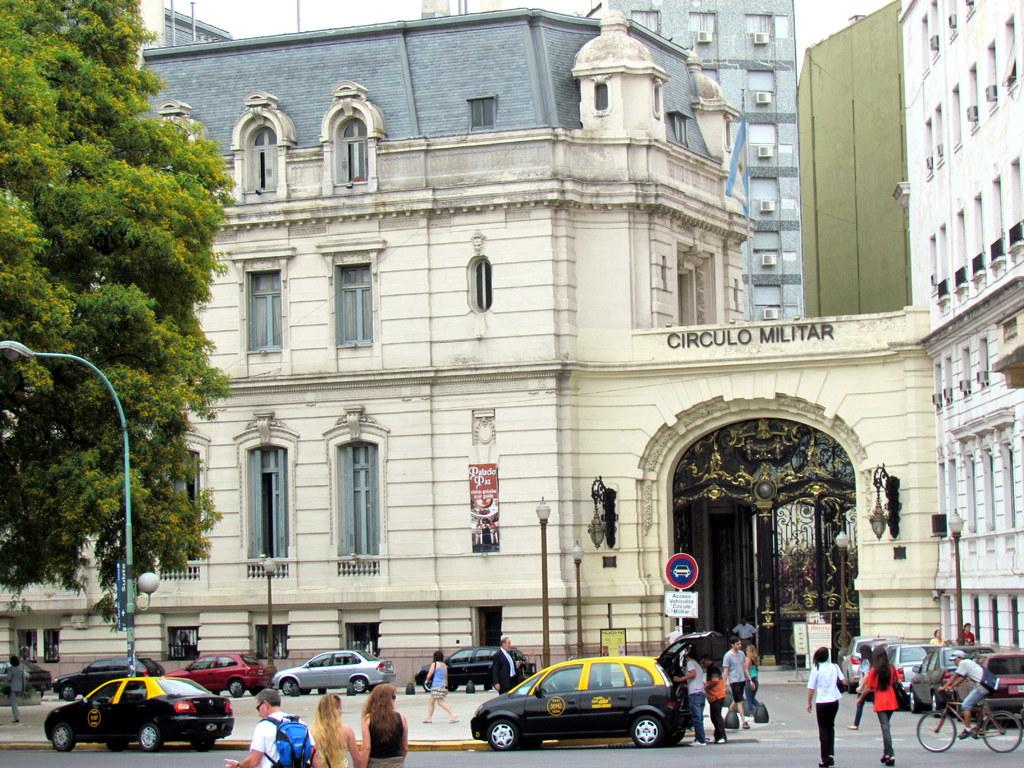<image>
Relay a brief, clear account of the picture shown. a building with the word circulo at the top of it 